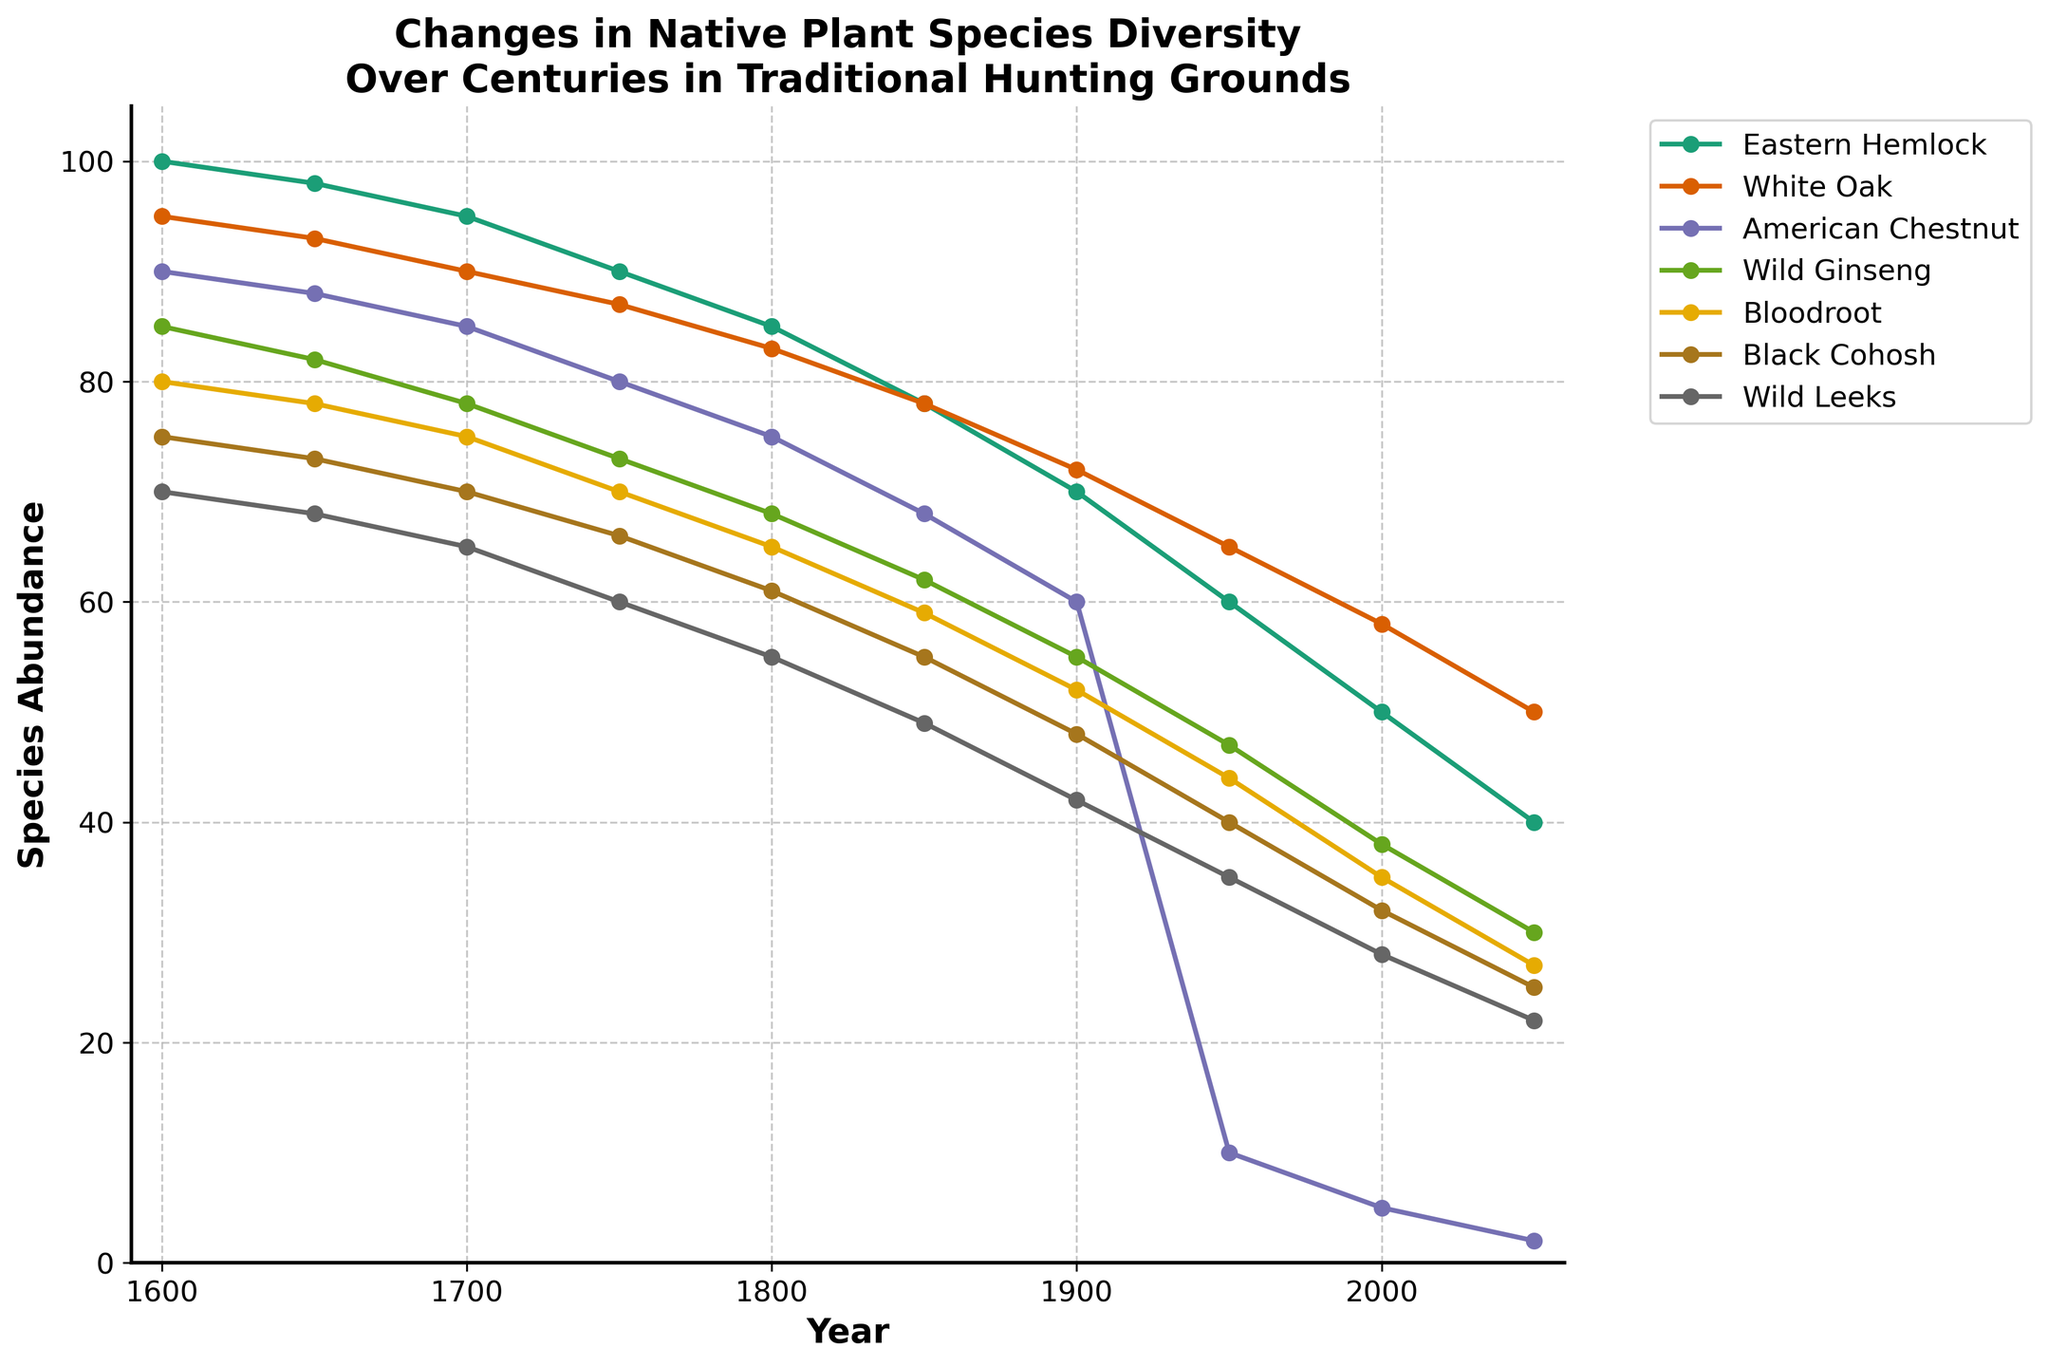Which plant species experienced the greatest decline in abundance from 1600 to 2050? To determine this, observe the starting and ending values for each species. The American Chestnut begins at 90 and ends at 2, a decline of 88. Compare this with the declines for the other species; the American Chestnut's decline is the largest.
Answer: American Chestnut What is the average abundance of Eastern Hemlock in the years 1600, 1700, and 1800? Calculate the average by summing the abundances in these years and dividing by the number of years: (100 + 95 + 85) / 3 = 280 / 3 = 93.33.
Answer: 93.33 Between the years 1900 and 1950, which species showed the least change in abundance? Look at the abundance values for each species in both years and calculate their differences. Eastern Hemlock: 70-60=10, White Oak: 72-65=7, American Chestnut: 60-10=50, Wild Ginseng: 55-47=8, Bloodroot: 52-44=8, Black Cohosh: 48-40=8, Wild Leeks: 42-35=7. White Oak and Wild Leeks both changed the least by 7.
Answer: White Oak and Wild Leeks In which century did the abundance of Wild Ginseng decrease the most? Calculate the decrease for each century: 
1600-1700: 85-78=7, 
1700-1800: 78-68=10, 
1800-1900: 68-55=13, 
1900-2000: 55-38=17, 
2000-2050: 38-30=8. The century from 1900 to 2000 saw the greatest decrease of 17.
Answer: 1900 to 2000 What is the difference in abundance between Bloodroot and Black Cohosh in 2000? Bloodroot had an abundance of 35 in 2000, while Black Cohosh had 32. The difference is 35 - 32 = 3.
Answer: 3 Which species had a higher abundance in 1650: White Oak or Wild Leeks? The graph shows White Oak's abundance at 93 and Wild Leeks at 68 in 1650. Since 93 is greater than 68, White Oak had a higher abundance.
Answer: White Oak How does the abundance of Black Cohosh in 1750 compare to its abundance in 2050? From the figure, Black Cohosh had an abundance of 66 in 1750 and 25 in 2050. 66 is greater than 25, indicating a higher abundance in 1750.
Answer: Higher in 1750 What was the combined abundance of Eastern Hemlock and White Oak in 1600? Simply add the abundances of the two species in that year: 100 (Eastern Hemlock) + 95 (White Oak) = 195.
Answer: 195 How many species had an abundance greater than 50 in the year 2000? Observing the year 2000, Eastern Hemlock (50), White Oak (58), and Bloodroot (35) are listed. Only three species have values greater than 50.
Answer: 2 